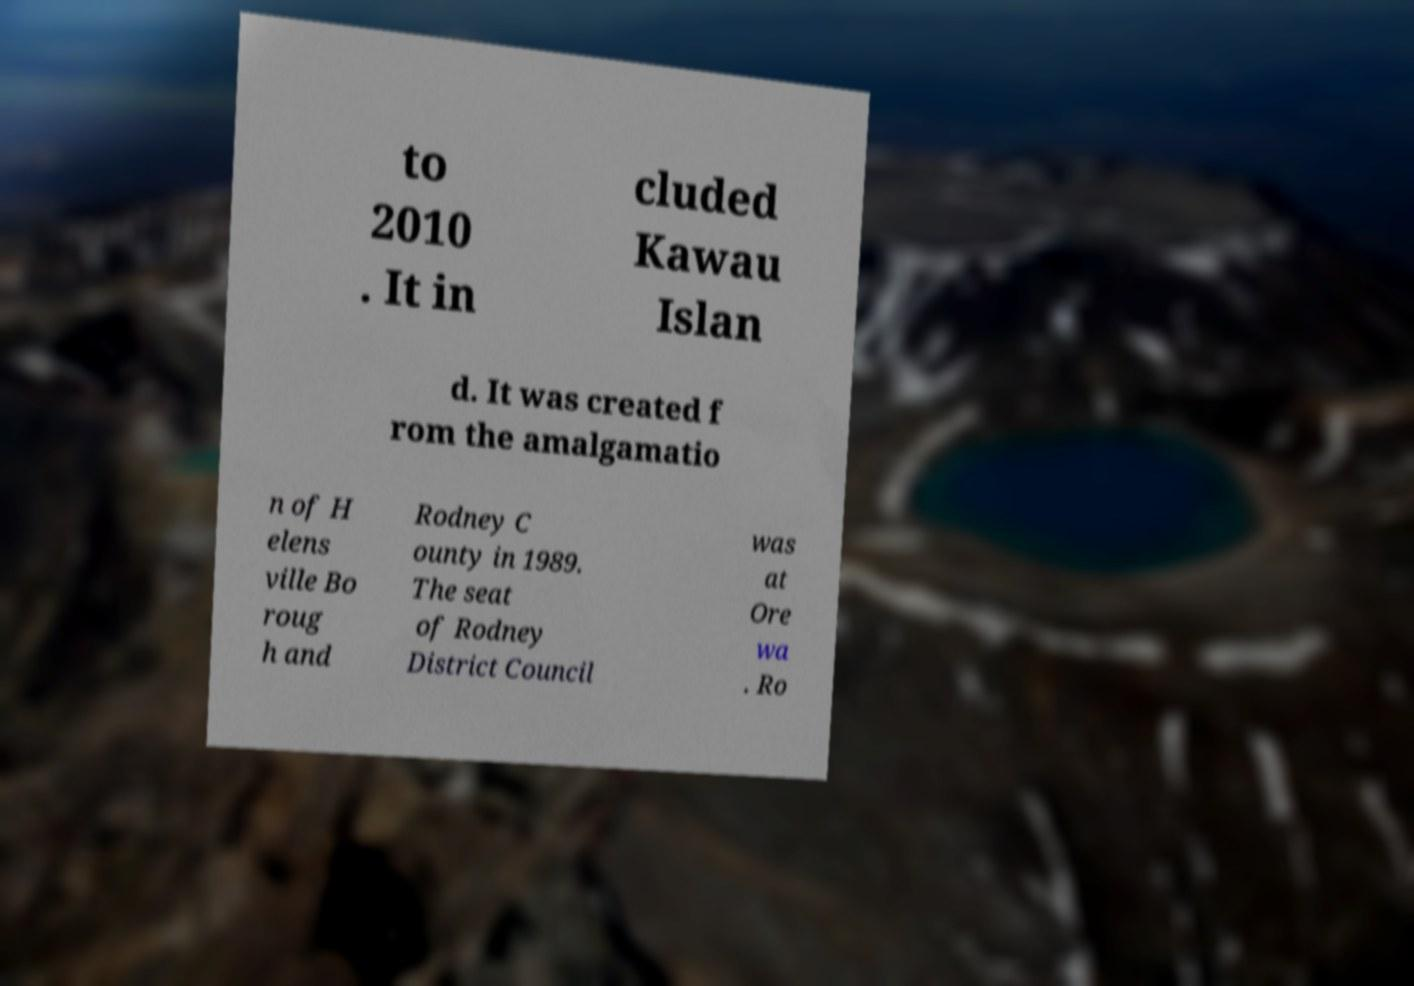Could you assist in decoding the text presented in this image and type it out clearly? to 2010 . It in cluded Kawau Islan d. It was created f rom the amalgamatio n of H elens ville Bo roug h and Rodney C ounty in 1989. The seat of Rodney District Council was at Ore wa . Ro 